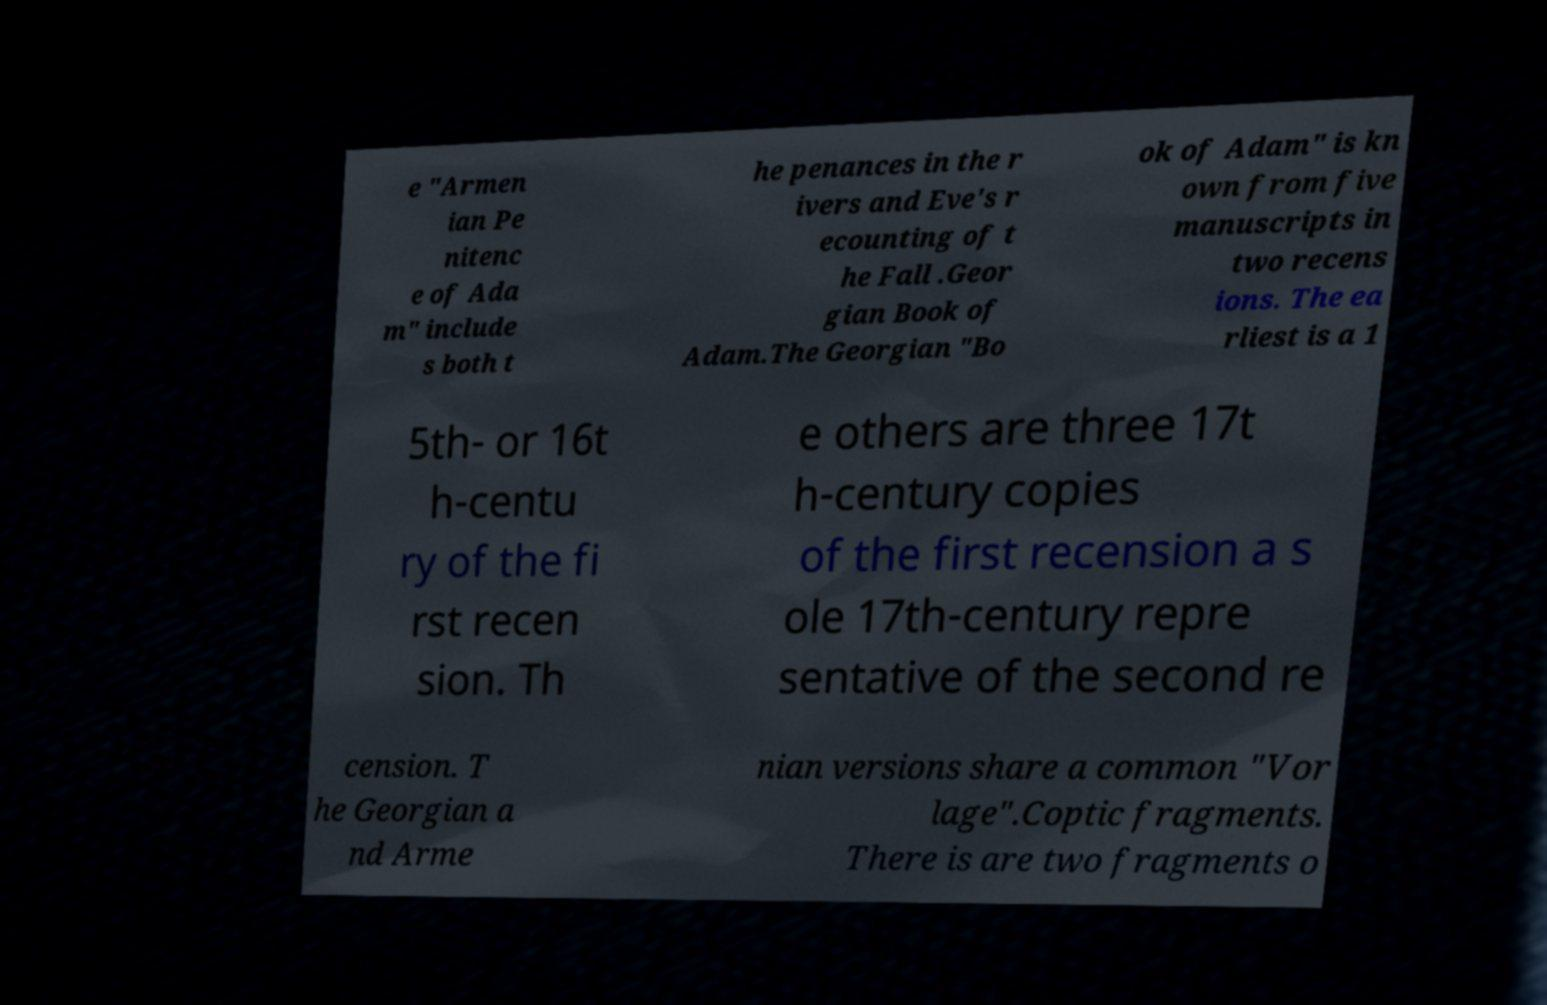What messages or text are displayed in this image? I need them in a readable, typed format. e "Armen ian Pe nitenc e of Ada m" include s both t he penances in the r ivers and Eve's r ecounting of t he Fall .Geor gian Book of Adam.The Georgian "Bo ok of Adam" is kn own from five manuscripts in two recens ions. The ea rliest is a 1 5th- or 16t h-centu ry of the fi rst recen sion. Th e others are three 17t h-century copies of the first recension a s ole 17th-century repre sentative of the second re cension. T he Georgian a nd Arme nian versions share a common "Vor lage".Coptic fragments. There is are two fragments o 